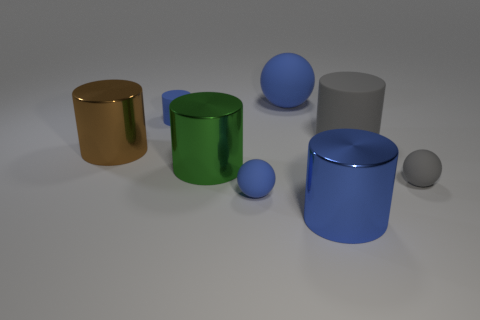Is there a brown thing made of the same material as the small cylinder?
Your response must be concise. No. The blue object to the right of the matte sphere behind the blue matte cylinder is made of what material?
Your answer should be very brief. Metal. What number of large blue matte things have the same shape as the large brown metal object?
Provide a succinct answer. 0. The large gray matte object is what shape?
Provide a succinct answer. Cylinder. Is the number of cyan shiny cubes less than the number of green objects?
Ensure brevity in your answer.  Yes. What is the material of the gray object that is the same shape as the big blue matte object?
Your answer should be compact. Rubber. Are there more gray cylinders than gray things?
Keep it short and to the point. No. How many other objects are there of the same color as the large matte cylinder?
Offer a very short reply. 1. Do the gray cylinder and the big cylinder that is in front of the small gray matte object have the same material?
Your answer should be very brief. No. There is a blue cylinder that is to the left of the tiny blue object that is in front of the large brown cylinder; how many blue matte objects are on the right side of it?
Keep it short and to the point. 2. 